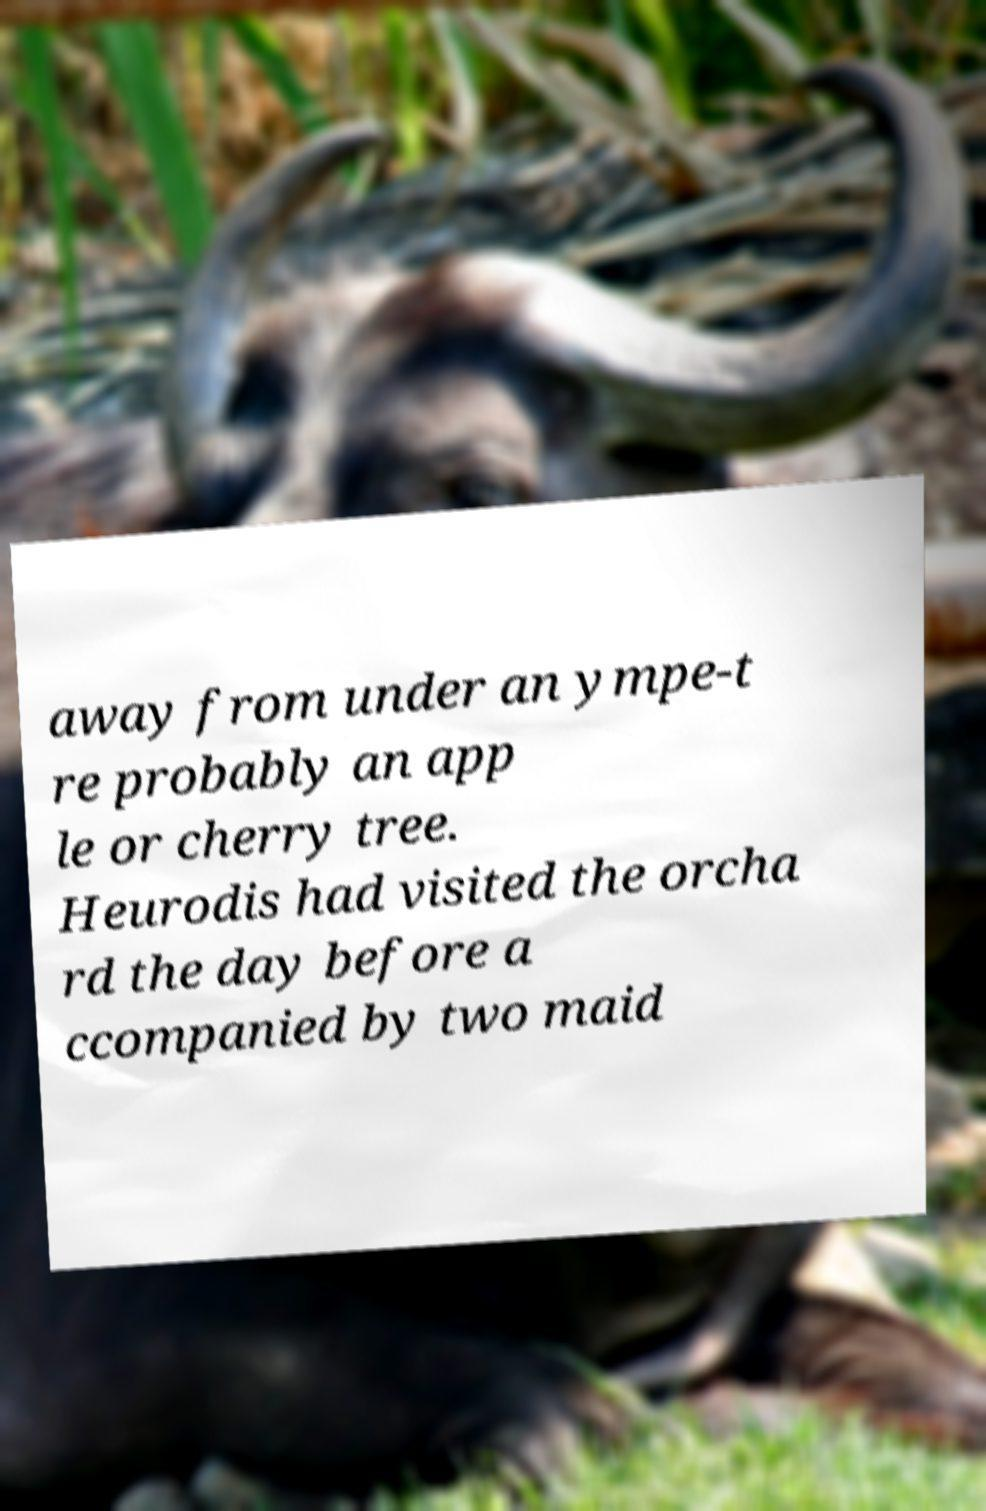There's text embedded in this image that I need extracted. Can you transcribe it verbatim? away from under an ympe-t re probably an app le or cherry tree. Heurodis had visited the orcha rd the day before a ccompanied by two maid 